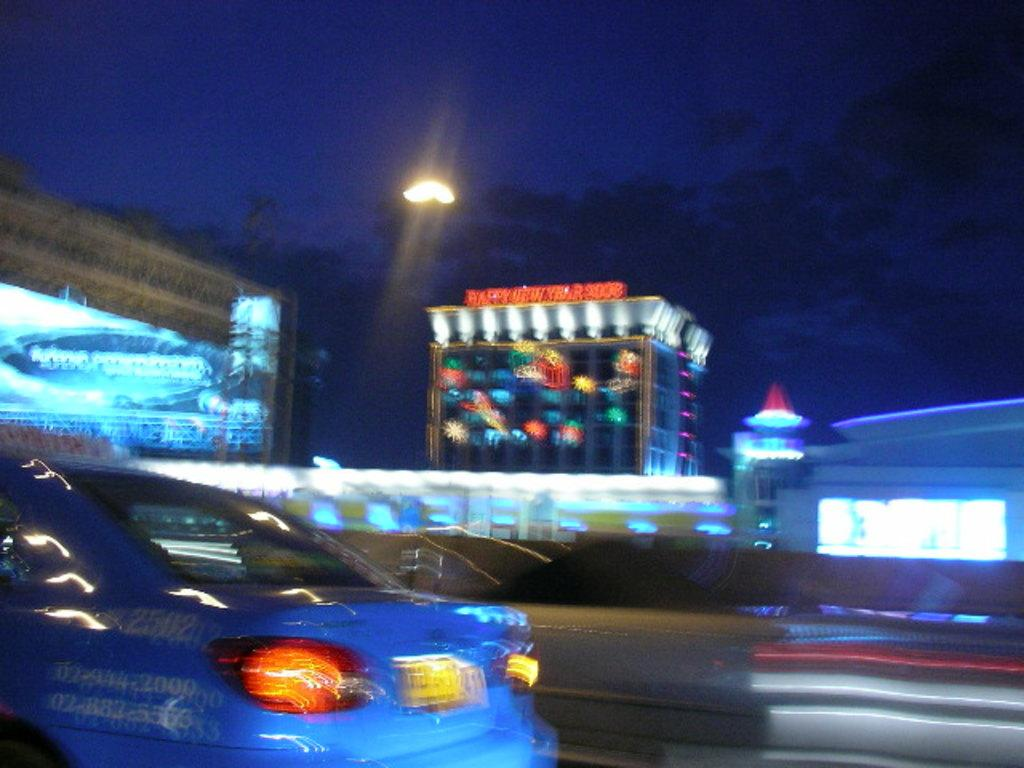What can be seen on the road in the image? There are cars on the road in the image. What structures are visible in the background of the image? There are buildings with lights in the background of the image. When was the image taken? The image was taken at night time. What is visible in the sky in the image? The sky is visible in the image, and clouds are present. Can you see any fairies flying around the cars in the image? No, there are no fairies present in the image. How many girls are visible in the image? There is no mention of girls in the provided facts, so we cannot determine their presence in the image. 